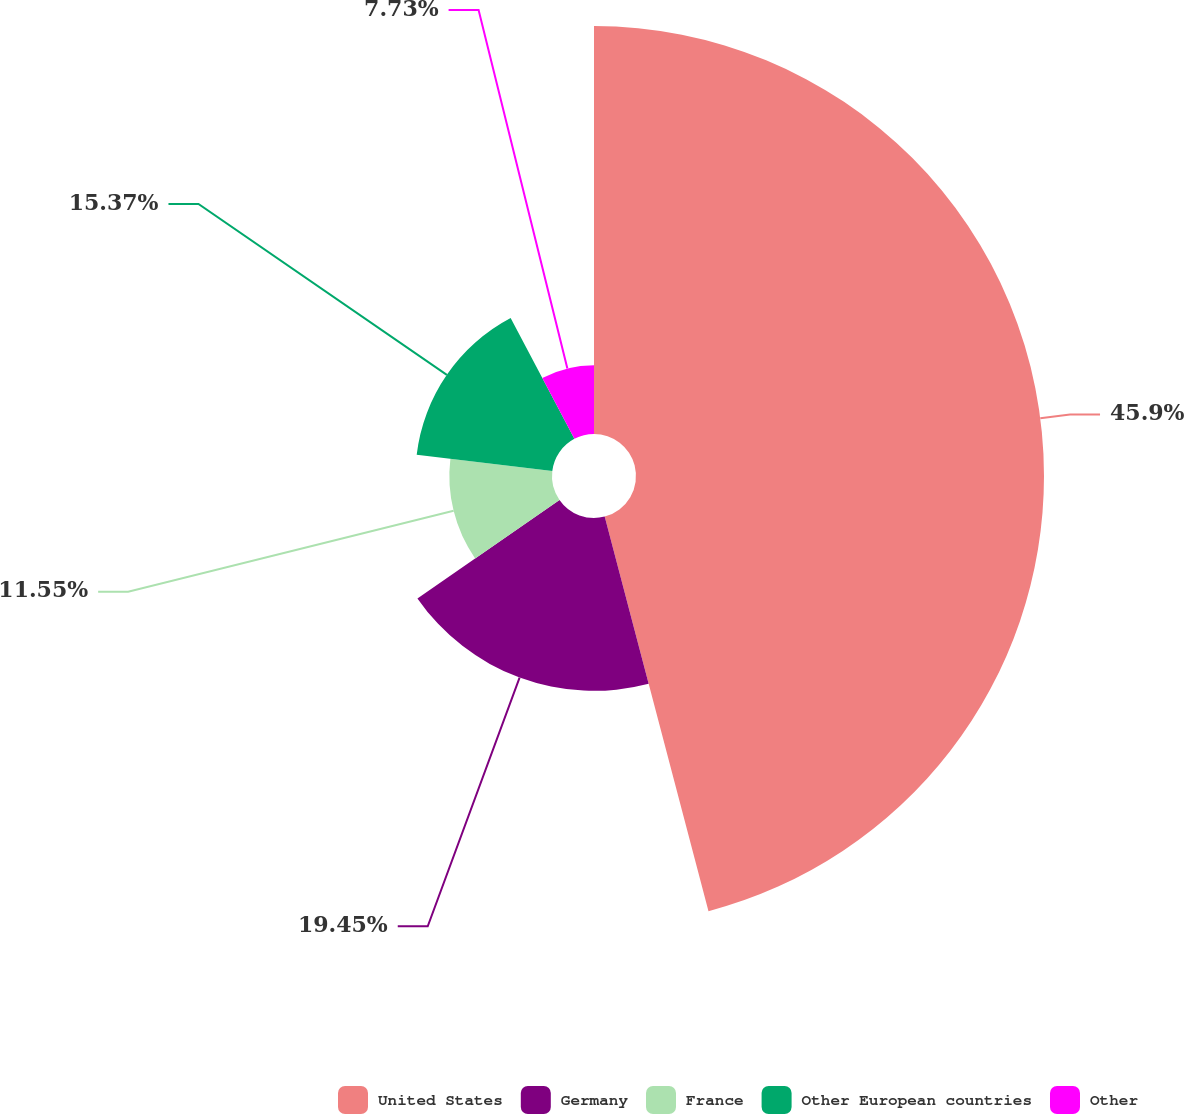<chart> <loc_0><loc_0><loc_500><loc_500><pie_chart><fcel>United States<fcel>Germany<fcel>France<fcel>Other European countries<fcel>Other<nl><fcel>45.91%<fcel>19.45%<fcel>11.55%<fcel>15.37%<fcel>7.73%<nl></chart> 